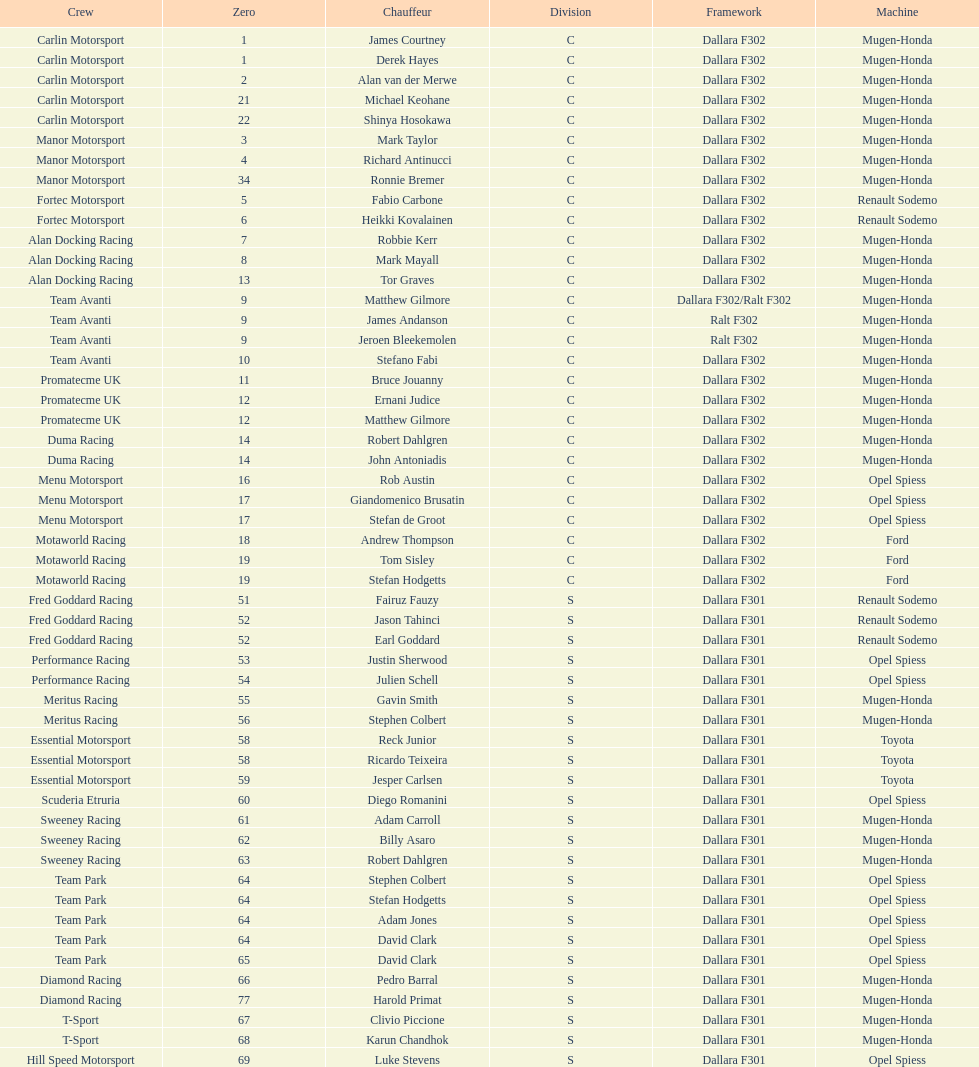Who had a greater number of drivers, team avanti or motaworld racing? Team Avanti. 